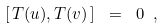<formula> <loc_0><loc_0><loc_500><loc_500>\left [ \, T ( u ) , T ( v ) \, \right ] \ = \ 0 \ ,</formula> 